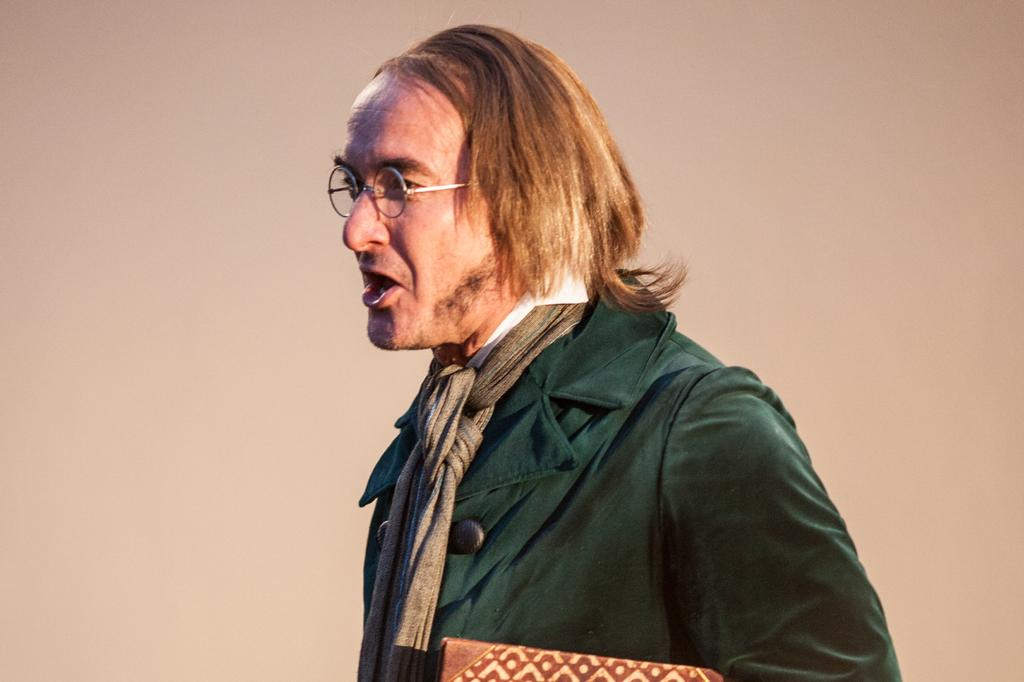What is the main subject of the image? There is a person standing in the image. What is the person wearing in the image? The person is wearing a green jacket. What accessory is the person wearing around their neck? The person has a scarf around their neck. How many feet are visible in the image? There is no mention of feet in the image, so it is impossible to determine how many are visible. 